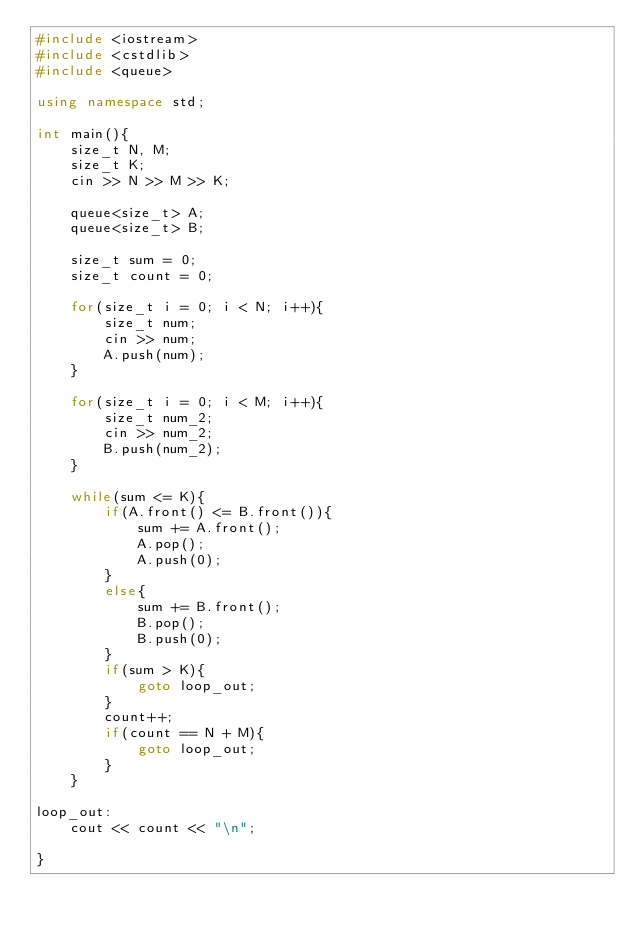<code> <loc_0><loc_0><loc_500><loc_500><_C++_>#include <iostream>
#include <cstdlib>
#include <queue>

using namespace std;

int main(){
	size_t N, M;
	size_t K;
	cin >> N >> M >> K;

	queue<size_t> A;
	queue<size_t> B;

	size_t sum = 0;
	size_t count = 0;

	for(size_t i = 0; i < N; i++){
		size_t num;	
		cin >> num;
		A.push(num);
	}

	for(size_t i = 0; i < M; i++){
		size_t num_2;
		cin >> num_2;
		B.push(num_2);
	}
	
	while(sum <= K){
		if(A.front() <= B.front()){
			sum += A.front();
			A.pop();
			A.push(0);
		}
		else{
			sum += B.front();
			B.pop();
			B.push(0);
		}
		if(sum > K){
			goto loop_out;
		}
		count++;
		if(count == N + M){
			goto loop_out;
		}
	}
	
loop_out:
	cout << count << "\n";

}

</code> 